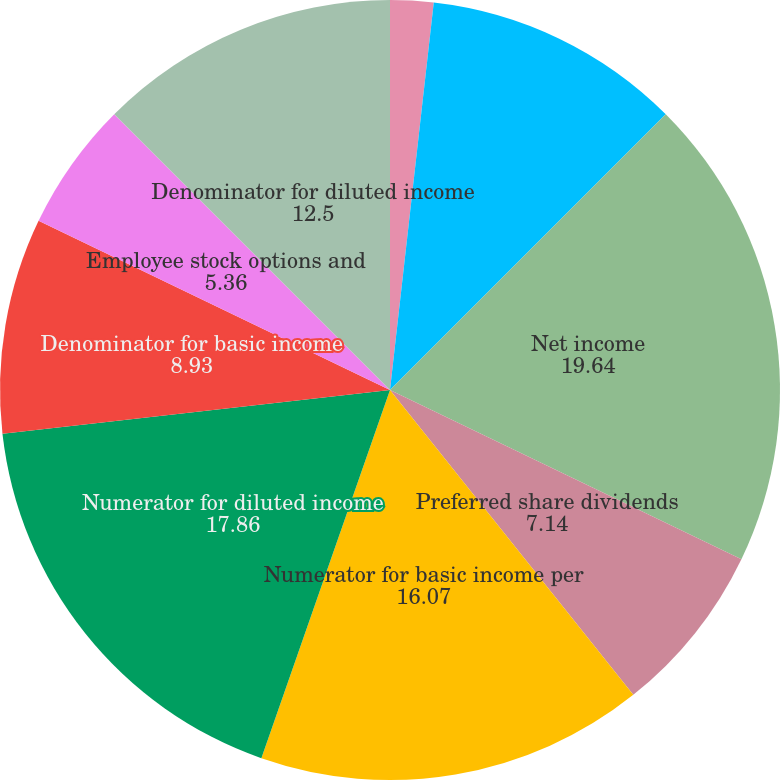<chart> <loc_0><loc_0><loc_500><loc_500><pie_chart><fcel>Income from continuing<fcel>Income from discontinued<fcel>Net income<fcel>Preferred share dividends<fcel>Numerator for basic income per<fcel>Numerator for diluted income<fcel>Denominator for basic income<fcel>Employee stock options and<fcel>Denominator for diluted income<nl><fcel>1.79%<fcel>10.71%<fcel>19.64%<fcel>7.14%<fcel>16.07%<fcel>17.86%<fcel>8.93%<fcel>5.36%<fcel>12.5%<nl></chart> 